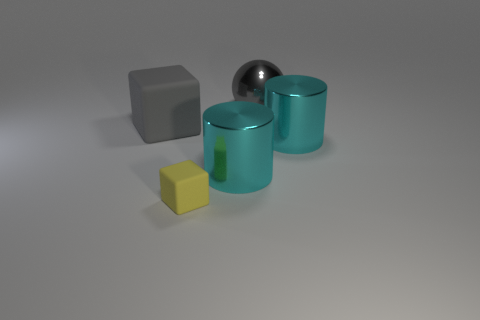What material is the block that is the same color as the ball?
Your response must be concise. Rubber. Are there any big things that have the same color as the large cube?
Provide a succinct answer. Yes. What is the color of the large matte object that is behind the rubber thing right of the rubber block left of the tiny yellow thing?
Offer a terse response. Gray. How many green matte cubes are there?
Ensure brevity in your answer.  0. What number of large things are either brown metal things or metal objects?
Ensure brevity in your answer.  3. What is the shape of the gray metallic thing that is the same size as the gray cube?
Provide a succinct answer. Sphere. Are there any other things that have the same size as the yellow object?
Your answer should be very brief. No. What is the material of the large gray object right of the block right of the big rubber block?
Your response must be concise. Metal. Does the gray block have the same size as the gray metallic object?
Your response must be concise. Yes. How many objects are either matte cubes that are to the left of the small yellow block or big gray matte things?
Ensure brevity in your answer.  1. 